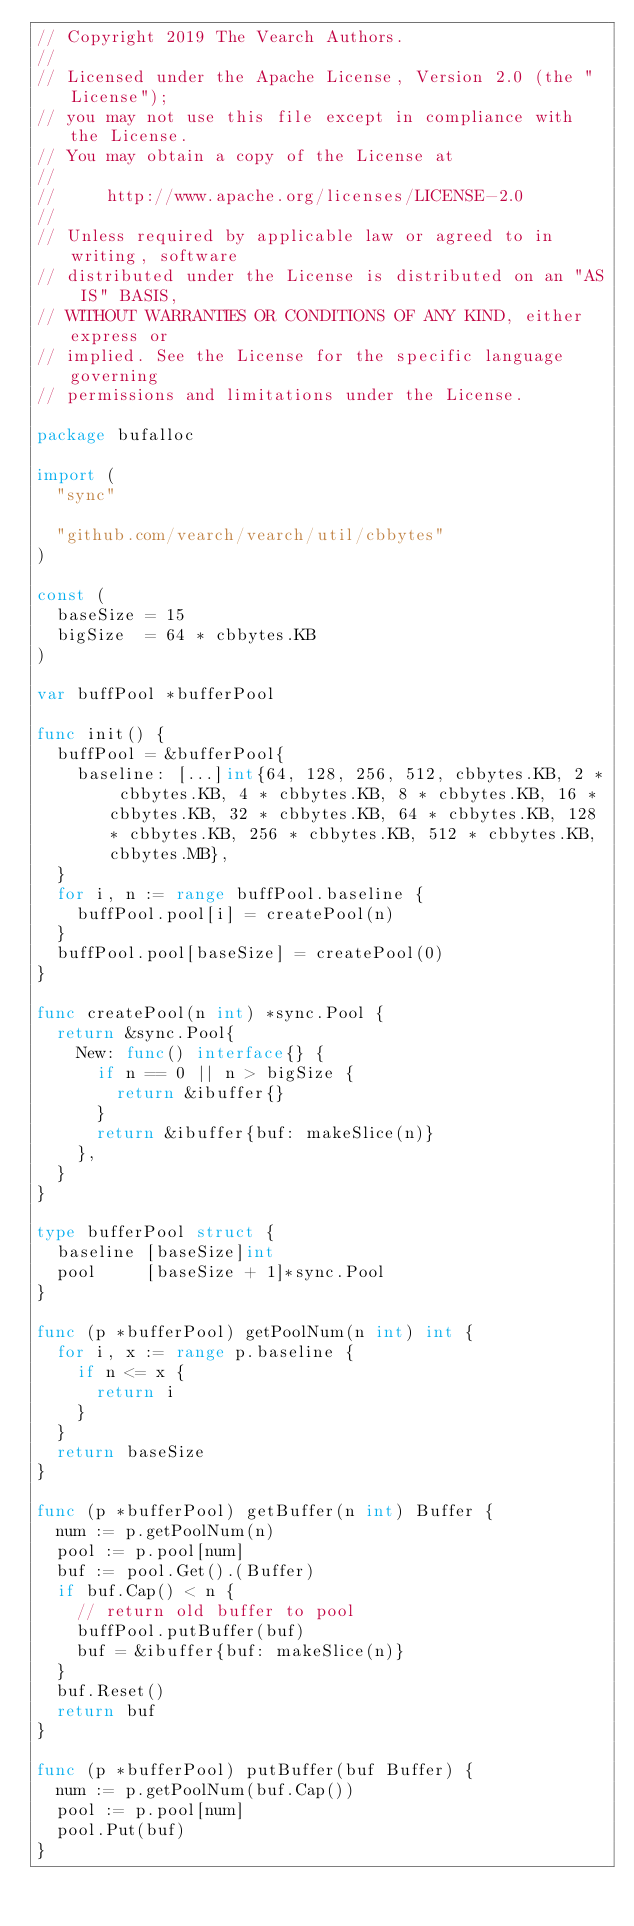<code> <loc_0><loc_0><loc_500><loc_500><_Go_>// Copyright 2019 The Vearch Authors.
//
// Licensed under the Apache License, Version 2.0 (the "License");
// you may not use this file except in compliance with the License.
// You may obtain a copy of the License at
//
//     http://www.apache.org/licenses/LICENSE-2.0
//
// Unless required by applicable law or agreed to in writing, software
// distributed under the License is distributed on an "AS IS" BASIS,
// WITHOUT WARRANTIES OR CONDITIONS OF ANY KIND, either express or
// implied. See the License for the specific language governing
// permissions and limitations under the License.

package bufalloc

import (
	"sync"

	"github.com/vearch/vearch/util/cbbytes"
)

const (
	baseSize = 15
	bigSize  = 64 * cbbytes.KB
)

var buffPool *bufferPool

func init() {
	buffPool = &bufferPool{
		baseline: [...]int{64, 128, 256, 512, cbbytes.KB, 2 * cbbytes.KB, 4 * cbbytes.KB, 8 * cbbytes.KB, 16 * cbbytes.KB, 32 * cbbytes.KB, 64 * cbbytes.KB, 128 * cbbytes.KB, 256 * cbbytes.KB, 512 * cbbytes.KB, cbbytes.MB},
	}
	for i, n := range buffPool.baseline {
		buffPool.pool[i] = createPool(n)
	}
	buffPool.pool[baseSize] = createPool(0)
}

func createPool(n int) *sync.Pool {
	return &sync.Pool{
		New: func() interface{} {
			if n == 0 || n > bigSize {
				return &ibuffer{}
			}
			return &ibuffer{buf: makeSlice(n)}
		},
	}
}

type bufferPool struct {
	baseline [baseSize]int
	pool     [baseSize + 1]*sync.Pool
}

func (p *bufferPool) getPoolNum(n int) int {
	for i, x := range p.baseline {
		if n <= x {
			return i
		}
	}
	return baseSize
}

func (p *bufferPool) getBuffer(n int) Buffer {
	num := p.getPoolNum(n)
	pool := p.pool[num]
	buf := pool.Get().(Buffer)
	if buf.Cap() < n {
		// return old buffer to pool
		buffPool.putBuffer(buf)
		buf = &ibuffer{buf: makeSlice(n)}
	}
	buf.Reset()
	return buf
}

func (p *bufferPool) putBuffer(buf Buffer) {
	num := p.getPoolNum(buf.Cap())
	pool := p.pool[num]
	pool.Put(buf)
}
</code> 